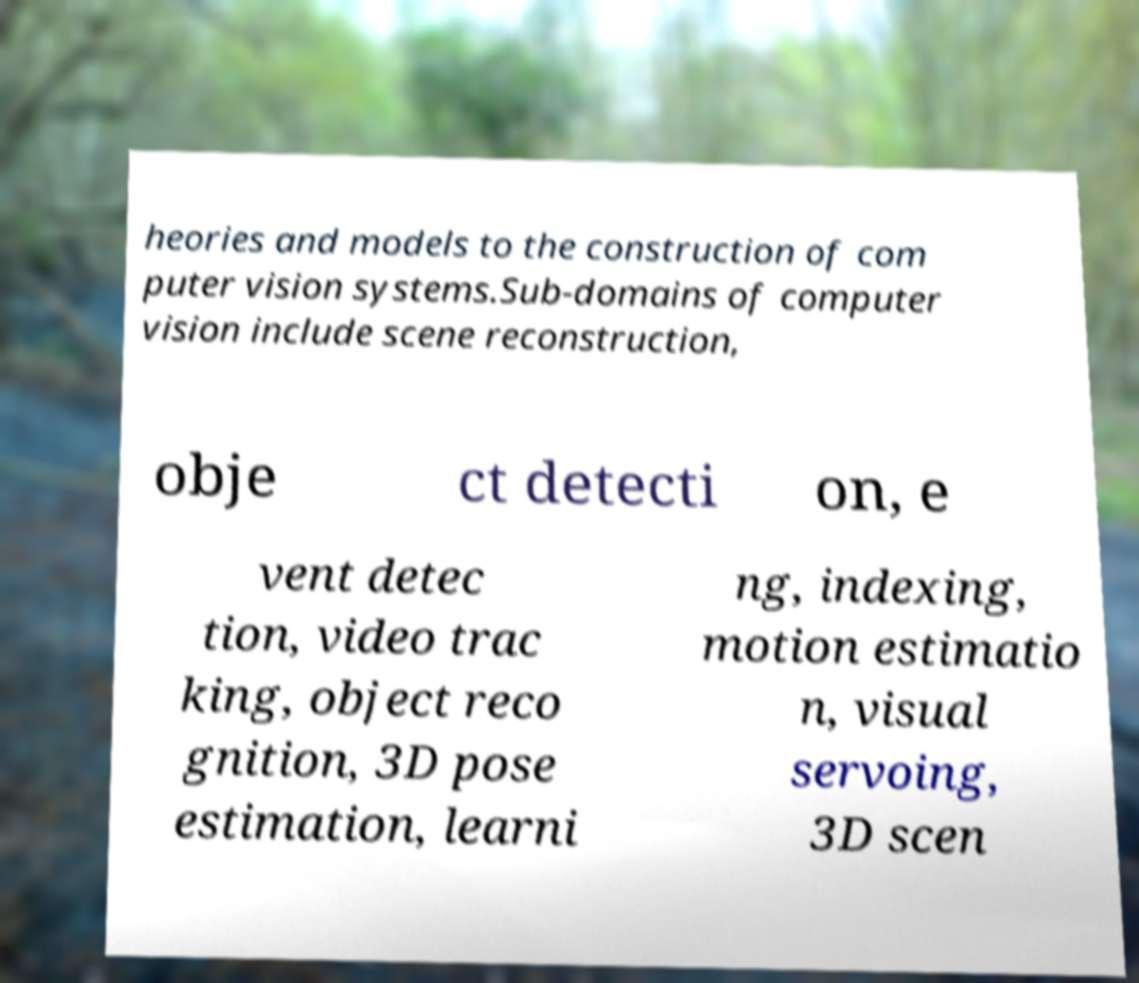For documentation purposes, I need the text within this image transcribed. Could you provide that? heories and models to the construction of com puter vision systems.Sub-domains of computer vision include scene reconstruction, obje ct detecti on, e vent detec tion, video trac king, object reco gnition, 3D pose estimation, learni ng, indexing, motion estimatio n, visual servoing, 3D scen 